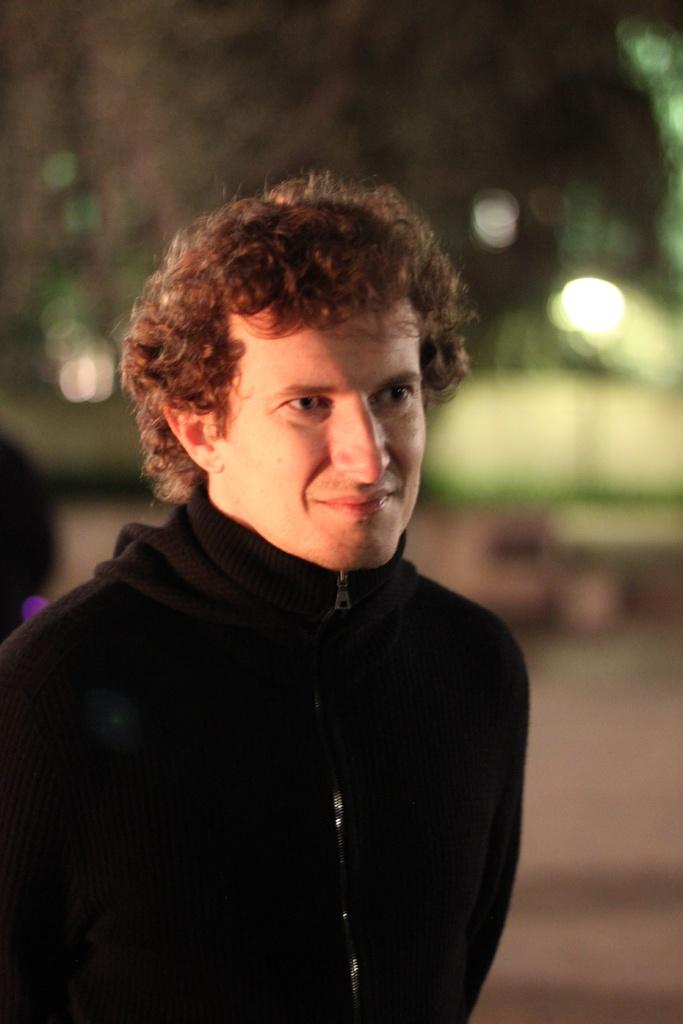Who is the main subject in the image? There is a man in the image. Where is the man located in the image? The man is in the middle of the image. What is the man wearing in the image? The man is wearing a sweater. How many geese are flying over the man in the image? There are no geese present in the image. What type of uncle is the man in the image? The image does not provide any information about the man's relationship to an uncle. 